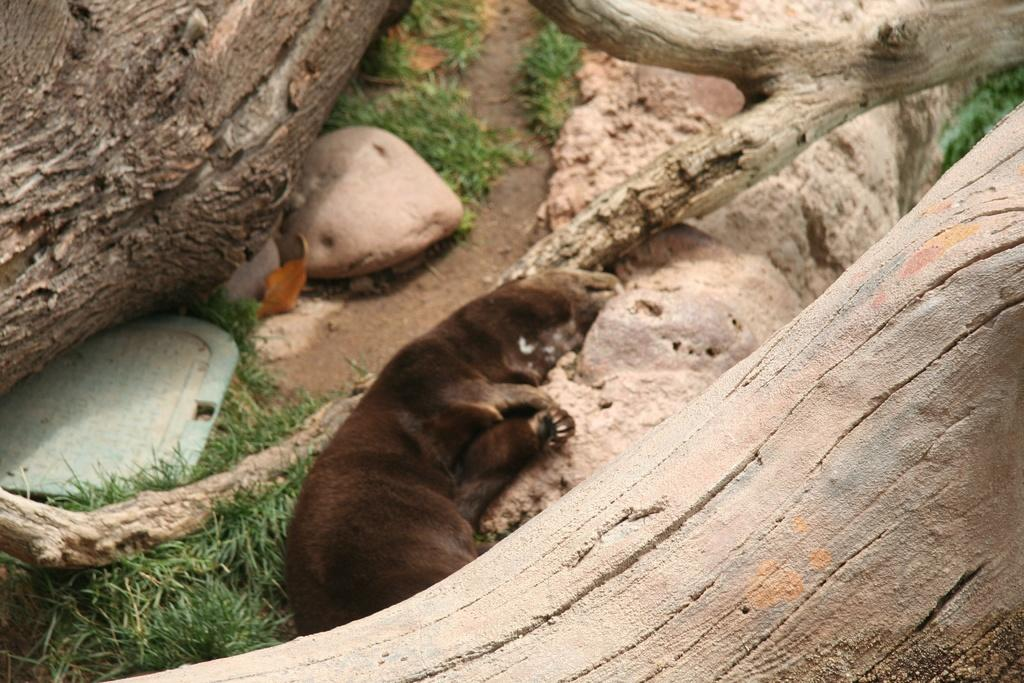What animal is laying on the ground in the image? There is a bear laying on the ground in the image. What type of vegetation can be seen in the image? There are tree trunks and grass visible in the image. What type of terrain is present in the image? There are stones in the image, indicating a rocky or uneven surface. Can you describe the unspecified object on the left side of the image? Unfortunately, the facts provided do not specify the nature of the object on the left side of the image. How many fangs does the bear have in the image? The image does not show the bear's teeth or fangs, so it is impossible to determine the number of fangs. Is there a camp visible in the image? There is no mention of a camp or any camping equipment in the provided facts, so it cannot be determined if a camp is present in the image. 